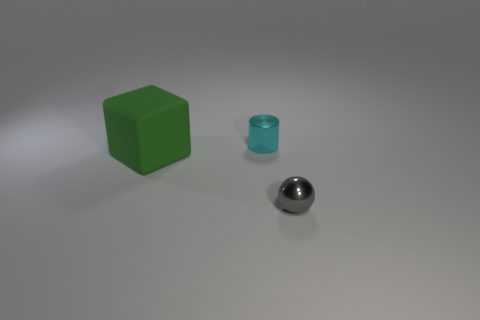Add 3 large cyan matte blocks. How many objects exist? 6 Subtract all balls. How many objects are left? 2 Add 1 big yellow spheres. How many big yellow spheres exist? 1 Subtract 0 brown cylinders. How many objects are left? 3 Subtract all gray rubber balls. Subtract all cyan cylinders. How many objects are left? 2 Add 1 cyan metallic cylinders. How many cyan metallic cylinders are left? 2 